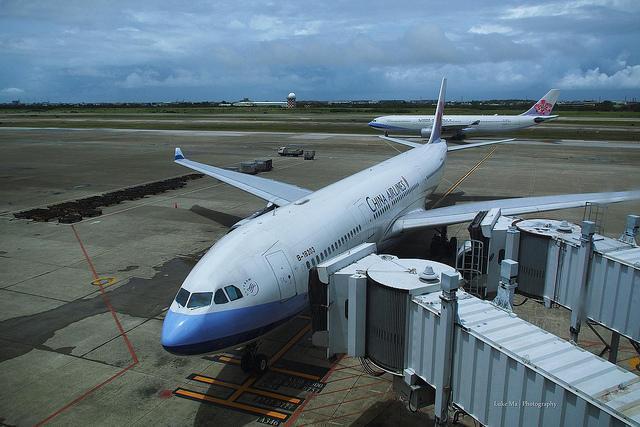How many airplanes are in the photo?
Give a very brief answer. 2. 